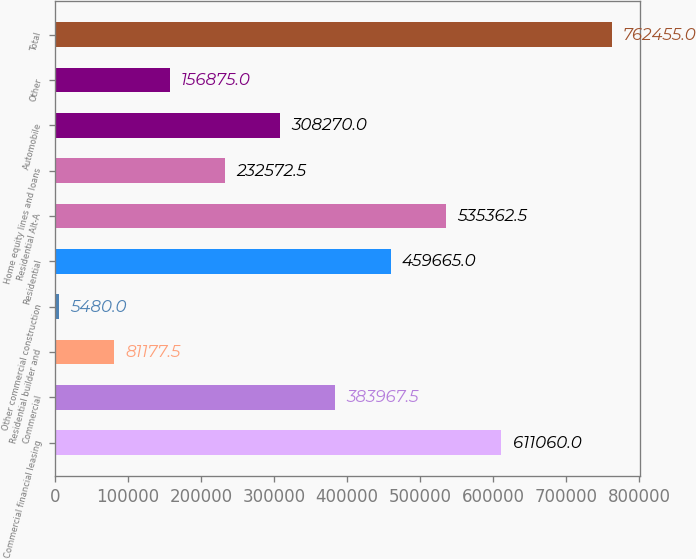<chart> <loc_0><loc_0><loc_500><loc_500><bar_chart><fcel>Commercial financial leasing<fcel>Commercial<fcel>Residential builder and<fcel>Other commercial construction<fcel>Residential<fcel>Residential Alt-A<fcel>Home equity lines and loans<fcel>Automobile<fcel>Other<fcel>Total<nl><fcel>611060<fcel>383968<fcel>81177.5<fcel>5480<fcel>459665<fcel>535362<fcel>232572<fcel>308270<fcel>156875<fcel>762455<nl></chart> 